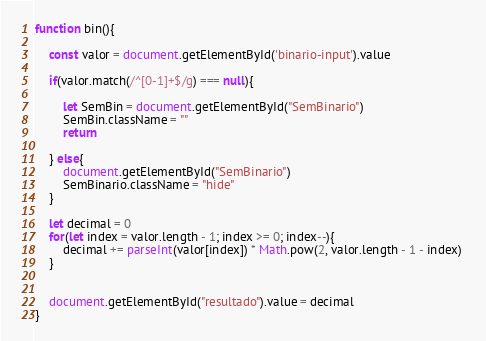Convert code to text. <code><loc_0><loc_0><loc_500><loc_500><_JavaScript_>function bin(){

    const valor = document.getElementById('binario-input').value
    
    if(valor.match(/^[0-1]+$/g) === null){
        
        let SemBin = document.getElementById("SemBinario")
        SemBin.className = ""
        return

    } else{
        document.getElementById("SemBinario")
        SemBinario.className = "hide"
    }

    let decimal = 0
    for(let index = valor.length - 1; index >= 0; index--){
        decimal += parseInt(valor[index]) * Math.pow(2, valor.length - 1 - index) 
    }


    document.getElementById("resultado").value = decimal
}
</code> 